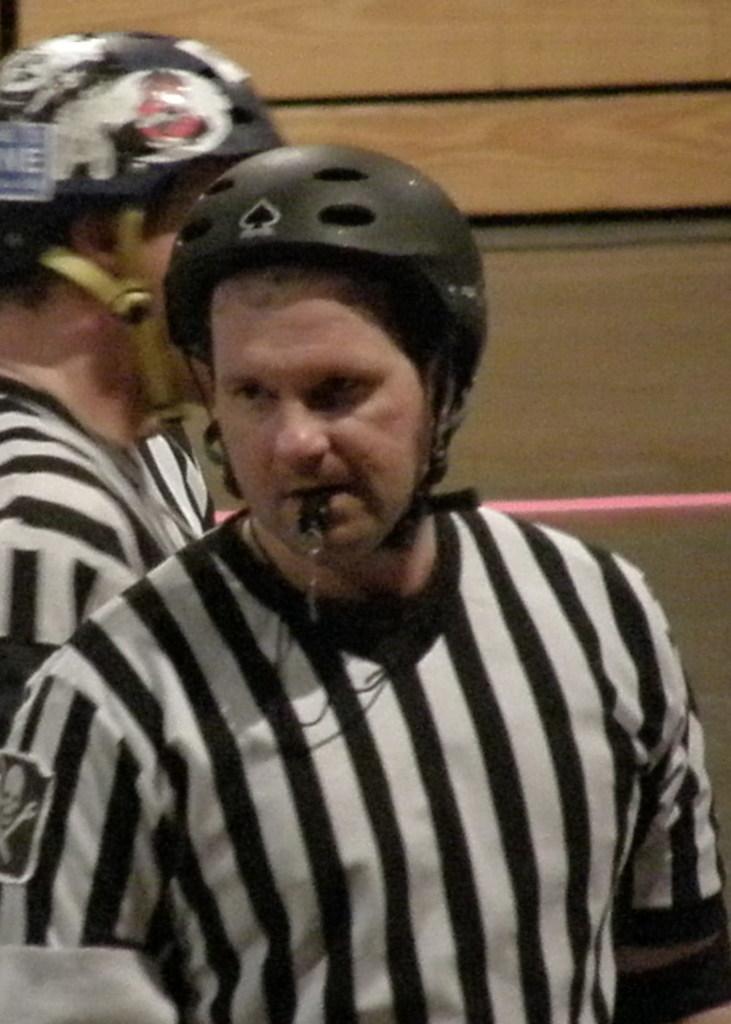Can you describe this image briefly? In this image there are two persons wearing helmets. 